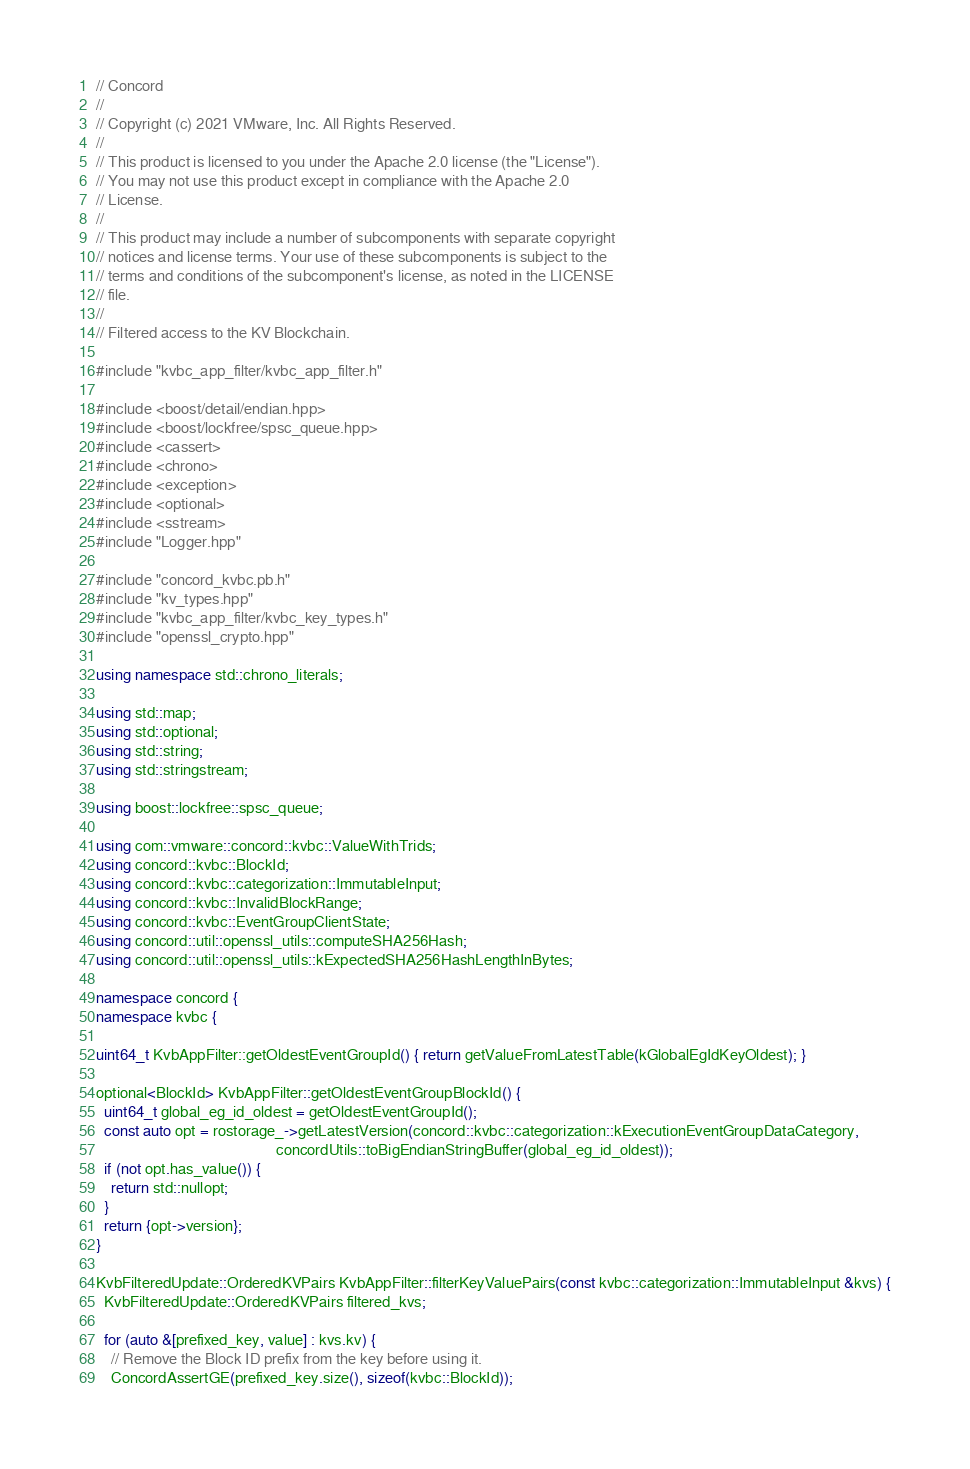<code> <loc_0><loc_0><loc_500><loc_500><_C++_>// Concord
//
// Copyright (c) 2021 VMware, Inc. All Rights Reserved.
//
// This product is licensed to you under the Apache 2.0 license (the "License").
// You may not use this product except in compliance with the Apache 2.0
// License.
//
// This product may include a number of subcomponents with separate copyright
// notices and license terms. Your use of these subcomponents is subject to the
// terms and conditions of the subcomponent's license, as noted in the LICENSE
// file.
//
// Filtered access to the KV Blockchain.

#include "kvbc_app_filter/kvbc_app_filter.h"

#include <boost/detail/endian.hpp>
#include <boost/lockfree/spsc_queue.hpp>
#include <cassert>
#include <chrono>
#include <exception>
#include <optional>
#include <sstream>
#include "Logger.hpp"

#include "concord_kvbc.pb.h"
#include "kv_types.hpp"
#include "kvbc_app_filter/kvbc_key_types.h"
#include "openssl_crypto.hpp"

using namespace std::chrono_literals;

using std::map;
using std::optional;
using std::string;
using std::stringstream;

using boost::lockfree::spsc_queue;

using com::vmware::concord::kvbc::ValueWithTrids;
using concord::kvbc::BlockId;
using concord::kvbc::categorization::ImmutableInput;
using concord::kvbc::InvalidBlockRange;
using concord::kvbc::EventGroupClientState;
using concord::util::openssl_utils::computeSHA256Hash;
using concord::util::openssl_utils::kExpectedSHA256HashLengthInBytes;

namespace concord {
namespace kvbc {

uint64_t KvbAppFilter::getOldestEventGroupId() { return getValueFromLatestTable(kGlobalEgIdKeyOldest); }

optional<BlockId> KvbAppFilter::getOldestEventGroupBlockId() {
  uint64_t global_eg_id_oldest = getOldestEventGroupId();
  const auto opt = rostorage_->getLatestVersion(concord::kvbc::categorization::kExecutionEventGroupDataCategory,
                                                concordUtils::toBigEndianStringBuffer(global_eg_id_oldest));
  if (not opt.has_value()) {
    return std::nullopt;
  }
  return {opt->version};
}

KvbFilteredUpdate::OrderedKVPairs KvbAppFilter::filterKeyValuePairs(const kvbc::categorization::ImmutableInput &kvs) {
  KvbFilteredUpdate::OrderedKVPairs filtered_kvs;

  for (auto &[prefixed_key, value] : kvs.kv) {
    // Remove the Block ID prefix from the key before using it.
    ConcordAssertGE(prefixed_key.size(), sizeof(kvbc::BlockId));</code> 